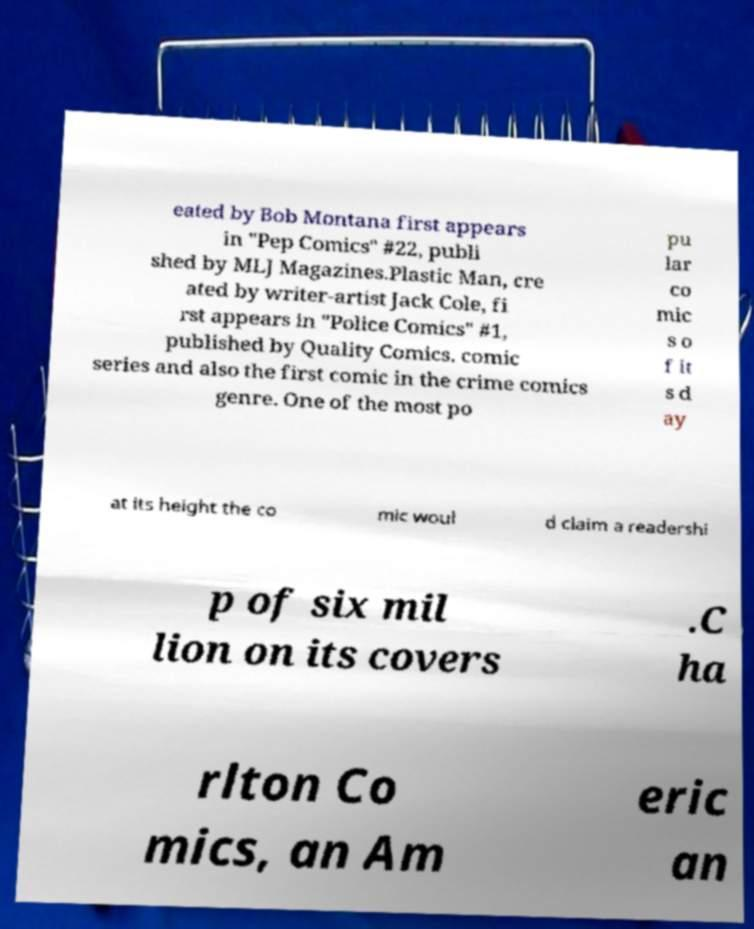Could you assist in decoding the text presented in this image and type it out clearly? eated by Bob Montana first appears in "Pep Comics" #22, publi shed by MLJ Magazines.Plastic Man, cre ated by writer-artist Jack Cole, fi rst appears in "Police Comics" #1, published by Quality Comics. comic series and also the first comic in the crime comics genre. One of the most po pu lar co mic s o f it s d ay at its height the co mic woul d claim a readershi p of six mil lion on its covers .C ha rlton Co mics, an Am eric an 